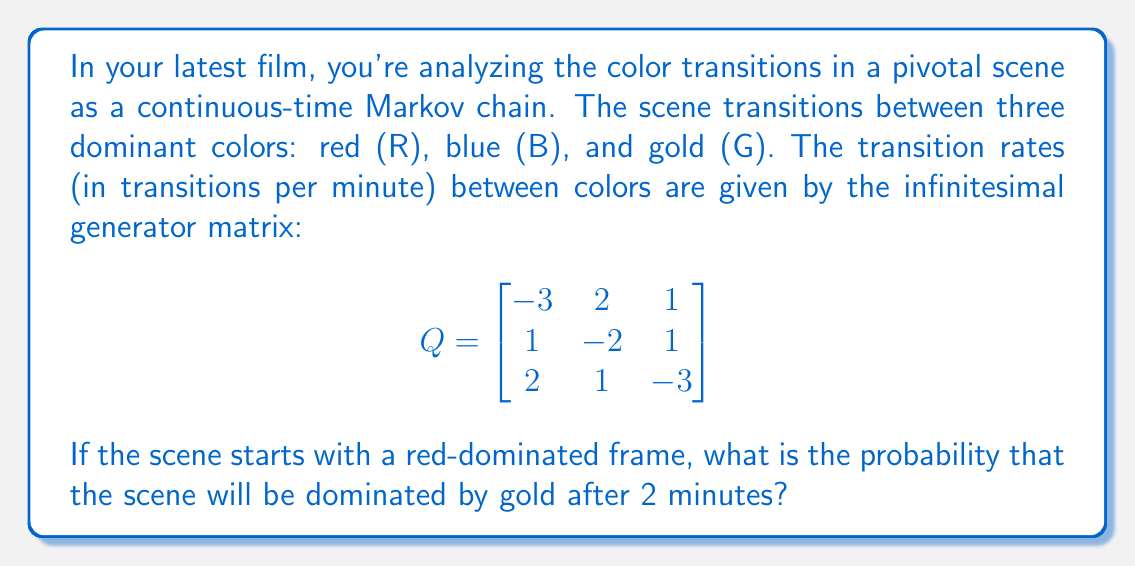What is the answer to this math problem? To solve this problem, we need to follow these steps:

1) First, we need to calculate the transition probability matrix $P(t)$ after 2 minutes. We can use the formula:

   $$P(t) = e^{Qt}$$

   where $e^{Qt}$ is the matrix exponential.

2) To calculate the matrix exponential, we can use the eigendecomposition method:

   $$e^{Qt} = V e^{\Lambda t} V^{-1}$$

   where $V$ is the matrix of eigenvectors and $\Lambda$ is the diagonal matrix of eigenvalues.

3) Calculate the eigenvalues of $Q$:
   
   $$\det(Q - \lambda I) = 0$$
   
   Solving this, we get: $\lambda_1 = 0, \lambda_2 = -4, \lambda_3 = -4$

4) Find the eigenvectors and construct $V$:

   $$V = \begin{bmatrix}
   1 & 1 & -1 \\
   1 & -1 & 1 \\
   1 & 0 & 0
   \end{bmatrix}$$

5) Calculate $V^{-1}$:

   $$V^{-1} = \frac{1}{3}\begin{bmatrix}
   1 & 1 & 1 \\
   1 & -1 & 2 \\
   -1 & 1 & 1
   \end{bmatrix}$$

6) Construct $e^{\Lambda t}$ for $t = 2$:

   $$e^{\Lambda t} = \begin{bmatrix}
   1 & 0 & 0 \\
   0 & e^{-8} & 0 \\
   0 & 0 & e^{-8}
   \end{bmatrix}$$

7) Calculate $P(2) = V e^{\Lambda 2} V^{-1}$:

   $$P(2) = \frac{1}{3}\begin{bmatrix}
   1+2e^{-8} & 1-e^{-8} & 1-e^{-8} \\
   1-e^{-8} & 1+2e^{-8} & 1-e^{-8} \\
   1-e^{-8} & 1-e^{-8} & 1+2e^{-8}
   \end{bmatrix}$$

8) The probability of transitioning from red (R) to gold (G) after 2 minutes is given by the element in the first row, third column of $P(2)$:

   $$P_{RG}(2) = \frac{1-e^{-8}}{3} \approx 0.3333$$
Answer: $\frac{1-e^{-8}}{3} \approx 0.3333$ 